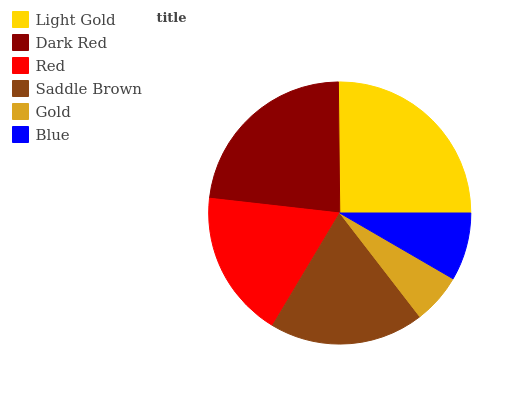Is Gold the minimum?
Answer yes or no. Yes. Is Light Gold the maximum?
Answer yes or no. Yes. Is Dark Red the minimum?
Answer yes or no. No. Is Dark Red the maximum?
Answer yes or no. No. Is Light Gold greater than Dark Red?
Answer yes or no. Yes. Is Dark Red less than Light Gold?
Answer yes or no. Yes. Is Dark Red greater than Light Gold?
Answer yes or no. No. Is Light Gold less than Dark Red?
Answer yes or no. No. Is Saddle Brown the high median?
Answer yes or no. Yes. Is Red the low median?
Answer yes or no. Yes. Is Blue the high median?
Answer yes or no. No. Is Saddle Brown the low median?
Answer yes or no. No. 